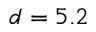Convert formula to latex. <formula><loc_0><loc_0><loc_500><loc_500>d = 5 . 2</formula> 